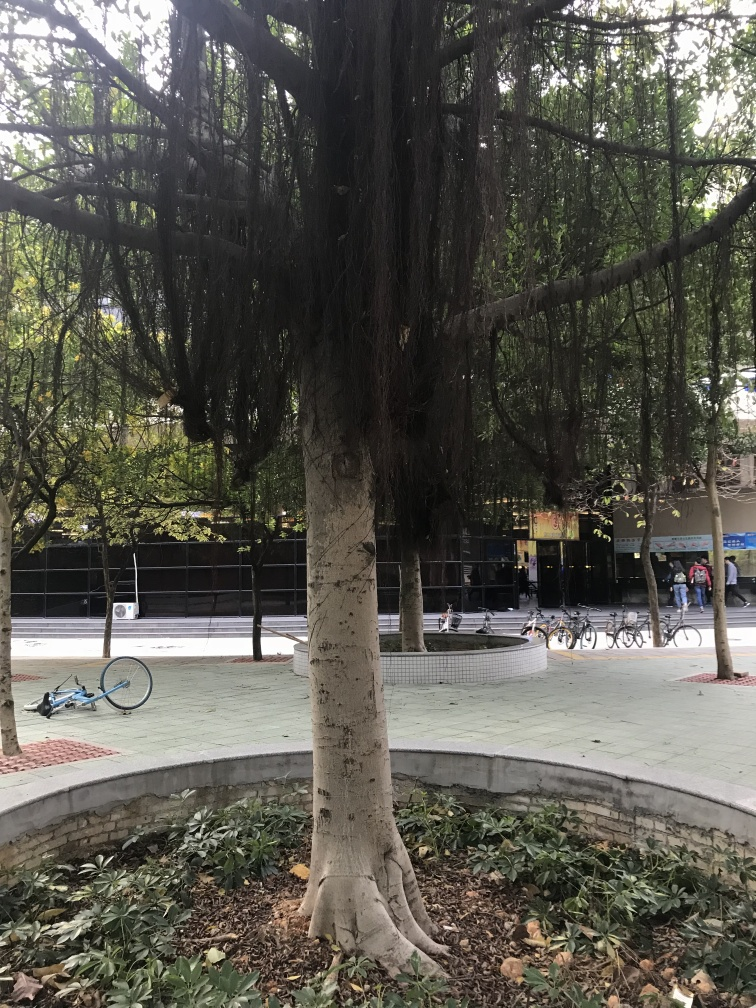What kind of place does this image depict, and what does it tell us about the area? The image shows a tree planted within an urban park or city square, as indicated by the paved walking paths and the bikes parked in the background. This scene suggests a city that values green spaces and offers inhabitants areas for relaxation and connection with nature despite the surrounding urban development. 